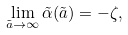<formula> <loc_0><loc_0><loc_500><loc_500>\lim _ { \tilde { a } \rightarrow \infty } \tilde { \alpha } ( \tilde { a } ) = - \zeta ,</formula> 